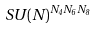<formula> <loc_0><loc_0><loc_500><loc_500>S U ( N ) ^ { N _ { 4 } N _ { 6 } N _ { 8 } }</formula> 